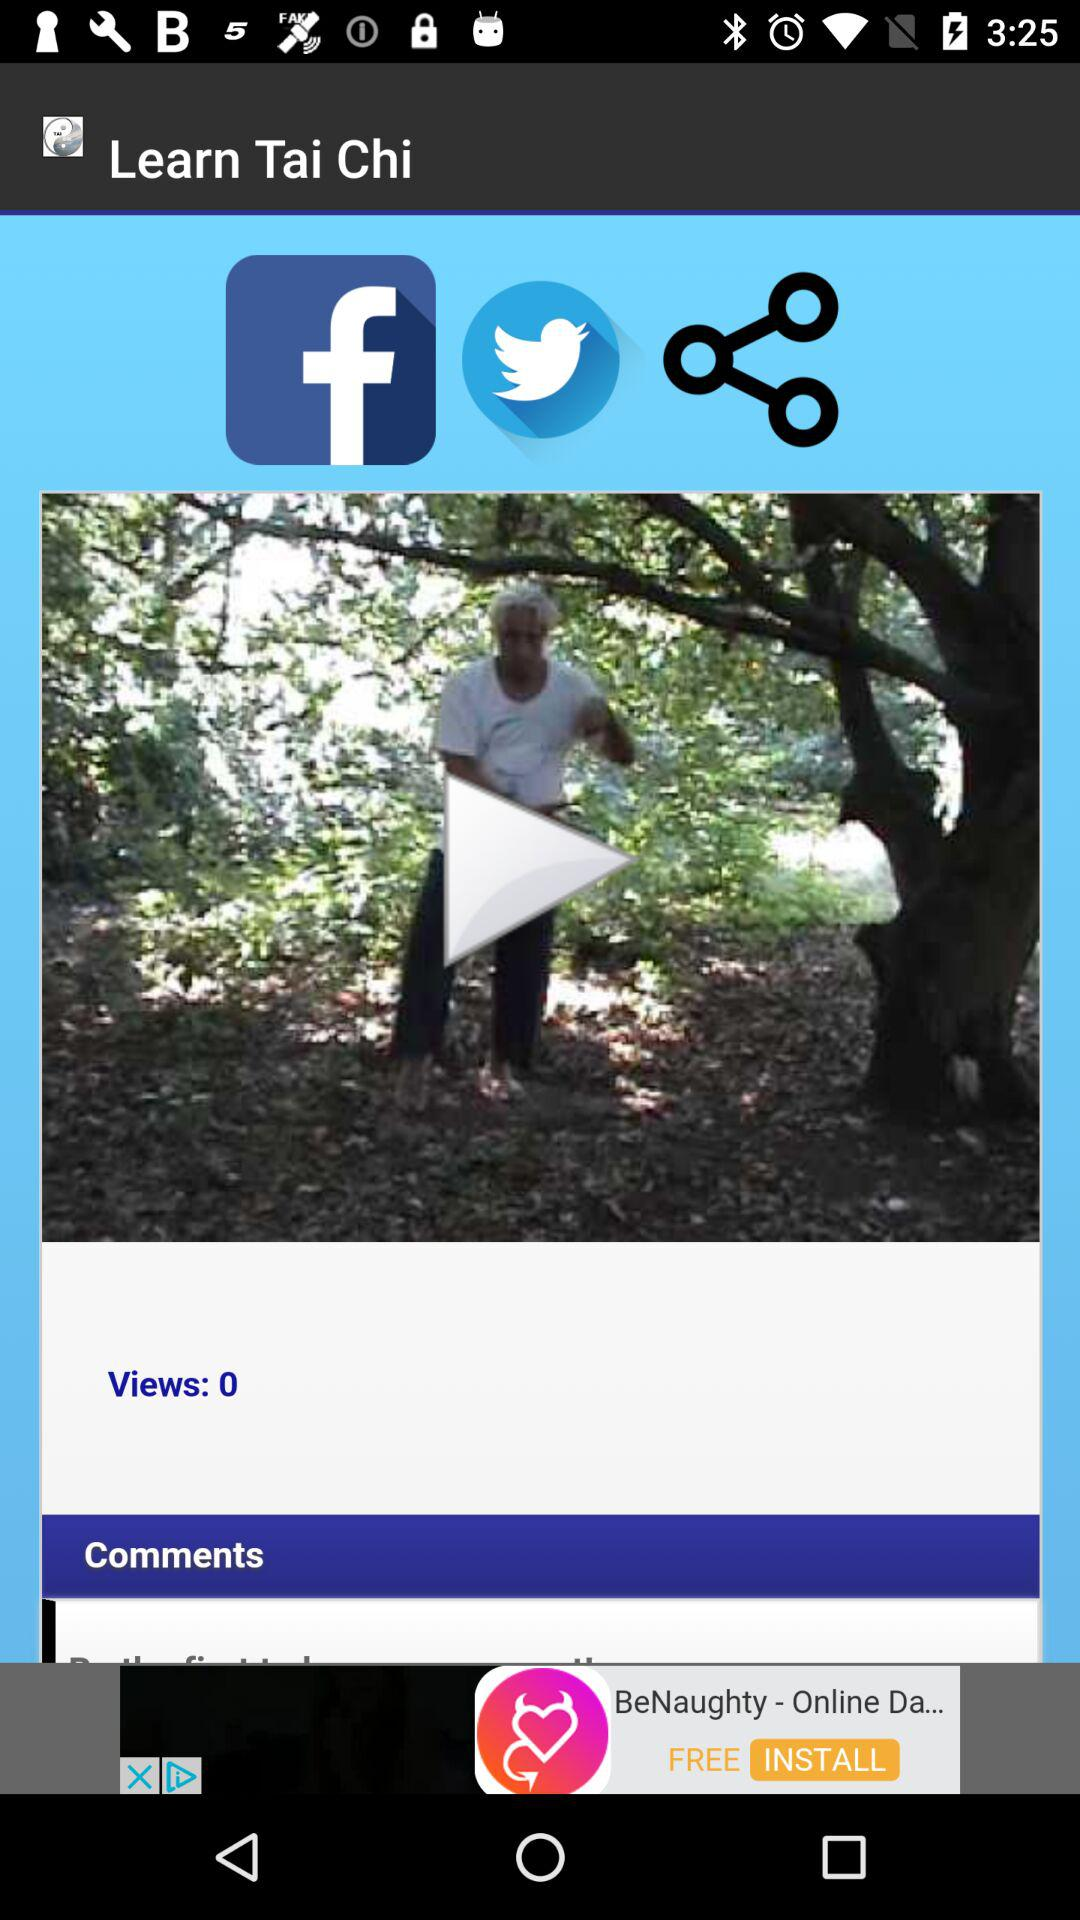What is the application name? The application name is "Learn Tai Chi". 